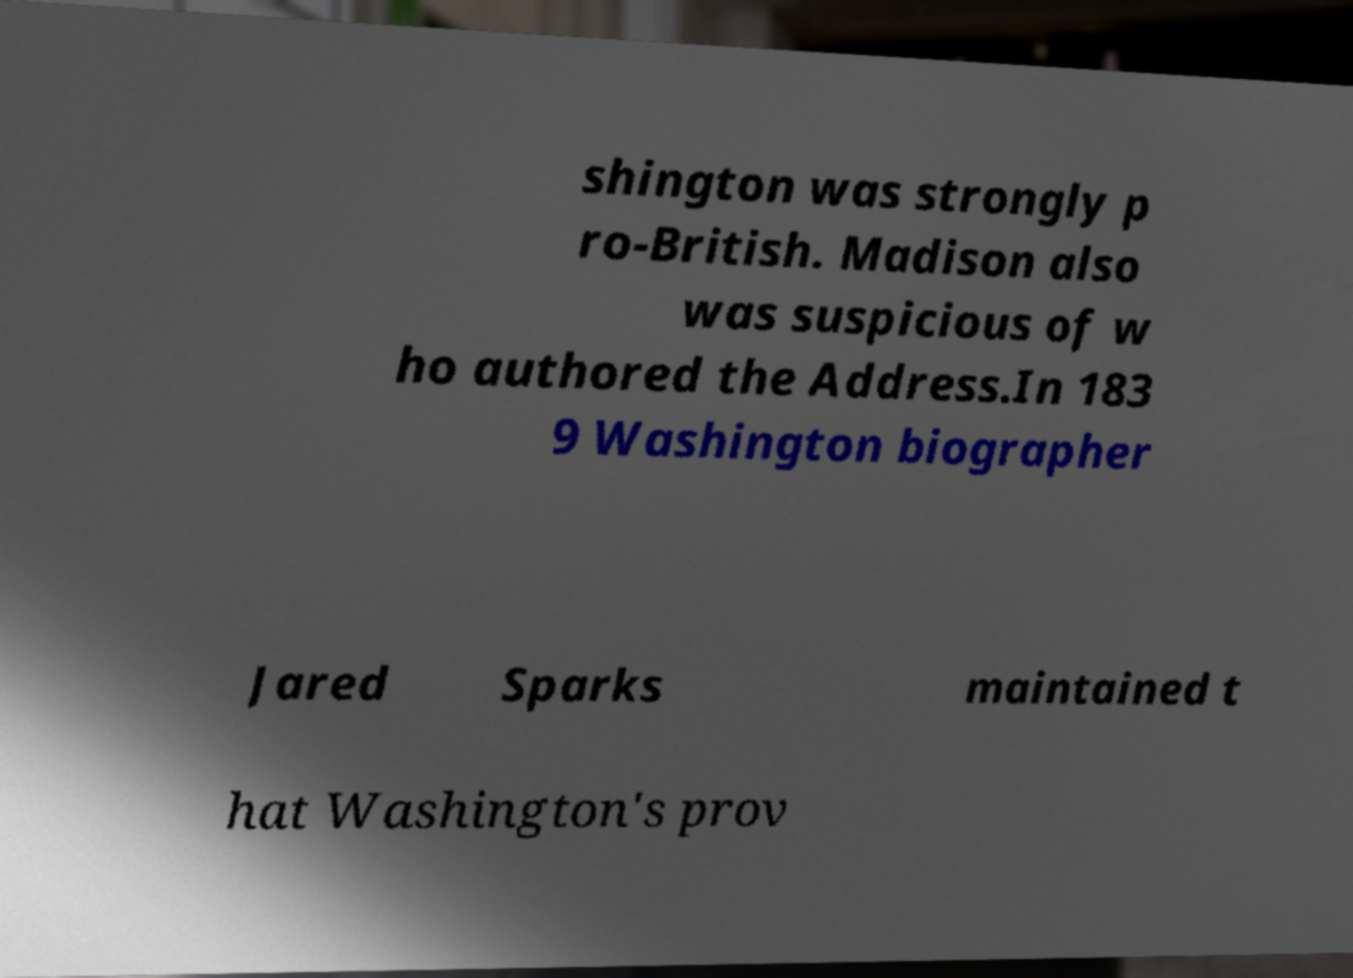For documentation purposes, I need the text within this image transcribed. Could you provide that? shington was strongly p ro-British. Madison also was suspicious of w ho authored the Address.In 183 9 Washington biographer Jared Sparks maintained t hat Washington's prov 